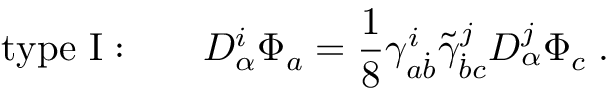<formula> <loc_0><loc_0><loc_500><loc_500>t y p e I \colon \quad D _ { \alpha } ^ { i } \Phi _ { a } = { \frac { 1 } { 8 } } \gamma _ { a \dot { b } } ^ { i } \tilde { \gamma } _ { \dot { b } c } ^ { j } D _ { \alpha } ^ { j } \Phi _ { c } \, .</formula> 